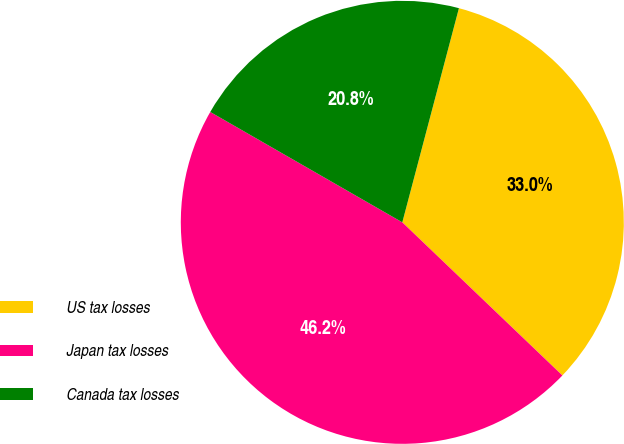Convert chart to OTSL. <chart><loc_0><loc_0><loc_500><loc_500><pie_chart><fcel>US tax losses<fcel>Japan tax losses<fcel>Canada tax losses<nl><fcel>33.03%<fcel>46.15%<fcel>20.81%<nl></chart> 